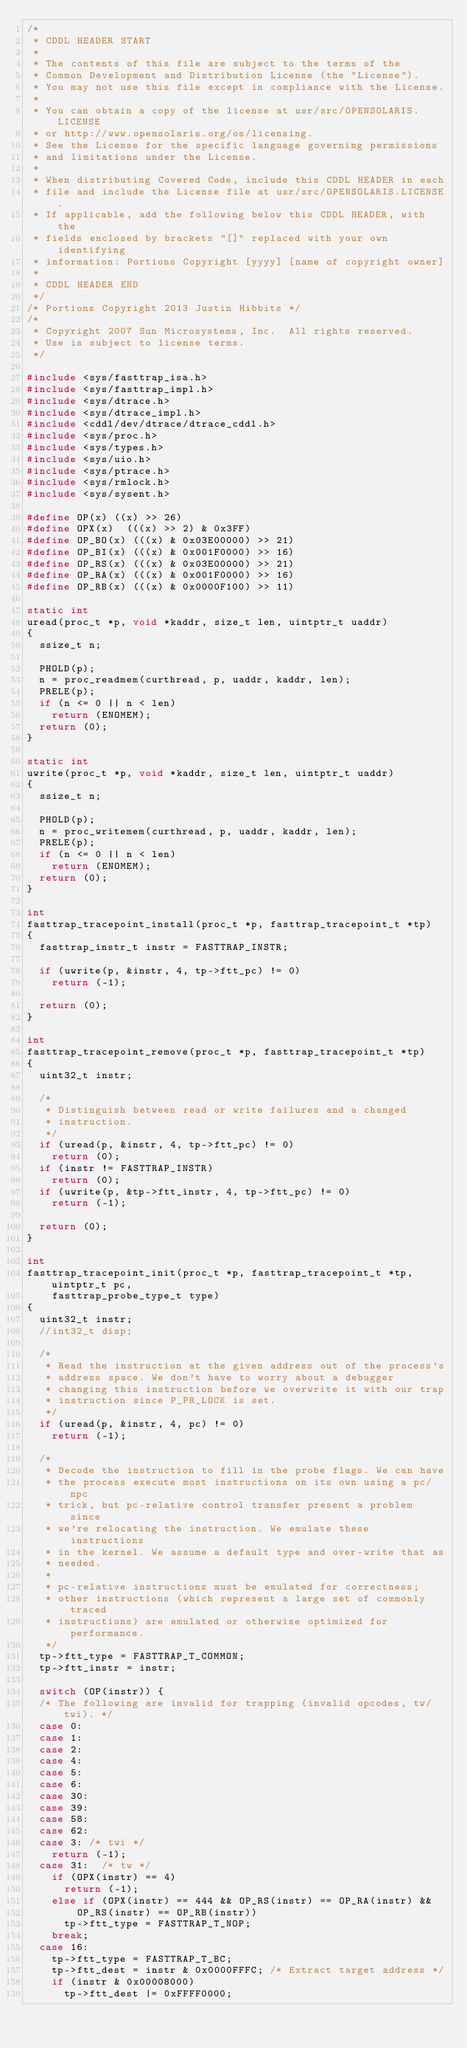Convert code to text. <code><loc_0><loc_0><loc_500><loc_500><_C_>/*
 * CDDL HEADER START
 *
 * The contents of this file are subject to the terms of the
 * Common Development and Distribution License (the "License").
 * You may not use this file except in compliance with the License.
 *
 * You can obtain a copy of the license at usr/src/OPENSOLARIS.LICENSE
 * or http://www.opensolaris.org/os/licensing.
 * See the License for the specific language governing permissions
 * and limitations under the License.
 *
 * When distributing Covered Code, include this CDDL HEADER in each
 * file and include the License file at usr/src/OPENSOLARIS.LICENSE.
 * If applicable, add the following below this CDDL HEADER, with the
 * fields enclosed by brackets "[]" replaced with your own identifying
 * information: Portions Copyright [yyyy] [name of copyright owner]
 *
 * CDDL HEADER END
 */
/* Portions Copyright 2013 Justin Hibbits */
/*
 * Copyright 2007 Sun Microsystems, Inc.  All rights reserved.
 * Use is subject to license terms.
 */

#include <sys/fasttrap_isa.h>
#include <sys/fasttrap_impl.h>
#include <sys/dtrace.h>
#include <sys/dtrace_impl.h>
#include <cddl/dev/dtrace/dtrace_cddl.h>
#include <sys/proc.h>
#include <sys/types.h>
#include <sys/uio.h>
#include <sys/ptrace.h>
#include <sys/rmlock.h>
#include <sys/sysent.h>

#define OP(x)	((x) >> 26)
#define OPX(x)	(((x) >> 2) & 0x3FF)
#define OP_BO(x) (((x) & 0x03E00000) >> 21)
#define OP_BI(x) (((x) & 0x001F0000) >> 16)
#define OP_RS(x) (((x) & 0x03E00000) >> 21)
#define OP_RA(x) (((x) & 0x001F0000) >> 16)
#define OP_RB(x) (((x) & 0x0000F100) >> 11)

static int
uread(proc_t *p, void *kaddr, size_t len, uintptr_t uaddr)
{
	ssize_t n;

	PHOLD(p);
	n = proc_readmem(curthread, p, uaddr, kaddr, len);
	PRELE(p);
	if (n <= 0 || n < len)
		return (ENOMEM);
	return (0);
}

static int
uwrite(proc_t *p, void *kaddr, size_t len, uintptr_t uaddr)
{
	ssize_t n;

	PHOLD(p);
	n = proc_writemem(curthread, p, uaddr, kaddr, len);
	PRELE(p);
	if (n <= 0 || n < len)
		return (ENOMEM);
	return (0);
}

int
fasttrap_tracepoint_install(proc_t *p, fasttrap_tracepoint_t *tp)
{
	fasttrap_instr_t instr = FASTTRAP_INSTR;

	if (uwrite(p, &instr, 4, tp->ftt_pc) != 0)
		return (-1);

	return (0);
}

int
fasttrap_tracepoint_remove(proc_t *p, fasttrap_tracepoint_t *tp)
{
	uint32_t instr;

	/*
	 * Distinguish between read or write failures and a changed
	 * instruction.
	 */
	if (uread(p, &instr, 4, tp->ftt_pc) != 0)
		return (0);
	if (instr != FASTTRAP_INSTR)
		return (0);
	if (uwrite(p, &tp->ftt_instr, 4, tp->ftt_pc) != 0)
		return (-1);

	return (0);
}

int
fasttrap_tracepoint_init(proc_t *p, fasttrap_tracepoint_t *tp, uintptr_t pc,
    fasttrap_probe_type_t type)
{
	uint32_t instr;
	//int32_t disp;

	/*
	 * Read the instruction at the given address out of the process's
	 * address space. We don't have to worry about a debugger
	 * changing this instruction before we overwrite it with our trap
	 * instruction since P_PR_LOCK is set.
	 */
	if (uread(p, &instr, 4, pc) != 0)
		return (-1);

	/*
	 * Decode the instruction to fill in the probe flags. We can have
	 * the process execute most instructions on its own using a pc/npc
	 * trick, but pc-relative control transfer present a problem since
	 * we're relocating the instruction. We emulate these instructions
	 * in the kernel. We assume a default type and over-write that as
	 * needed.
	 *
	 * pc-relative instructions must be emulated for correctness;
	 * other instructions (which represent a large set of commonly traced
	 * instructions) are emulated or otherwise optimized for performance.
	 */
	tp->ftt_type = FASTTRAP_T_COMMON;
	tp->ftt_instr = instr;

	switch (OP(instr)) {
	/* The following are invalid for trapping (invalid opcodes, tw/twi). */
	case 0:
	case 1:
	case 2:
	case 4:
	case 5:
	case 6:
	case 30:
	case 39:
	case 58:
	case 62:
	case 3:	/* twi */
		return (-1);
	case 31:	/* tw */
		if (OPX(instr) == 4)
			return (-1);
		else if (OPX(instr) == 444 && OP_RS(instr) == OP_RA(instr) &&
		    OP_RS(instr) == OP_RB(instr))
			tp->ftt_type = FASTTRAP_T_NOP;
		break;
	case 16:
		tp->ftt_type = FASTTRAP_T_BC;
		tp->ftt_dest = instr & 0x0000FFFC; /* Extract target address */
		if (instr & 0x00008000)
			tp->ftt_dest |= 0xFFFF0000;</code> 